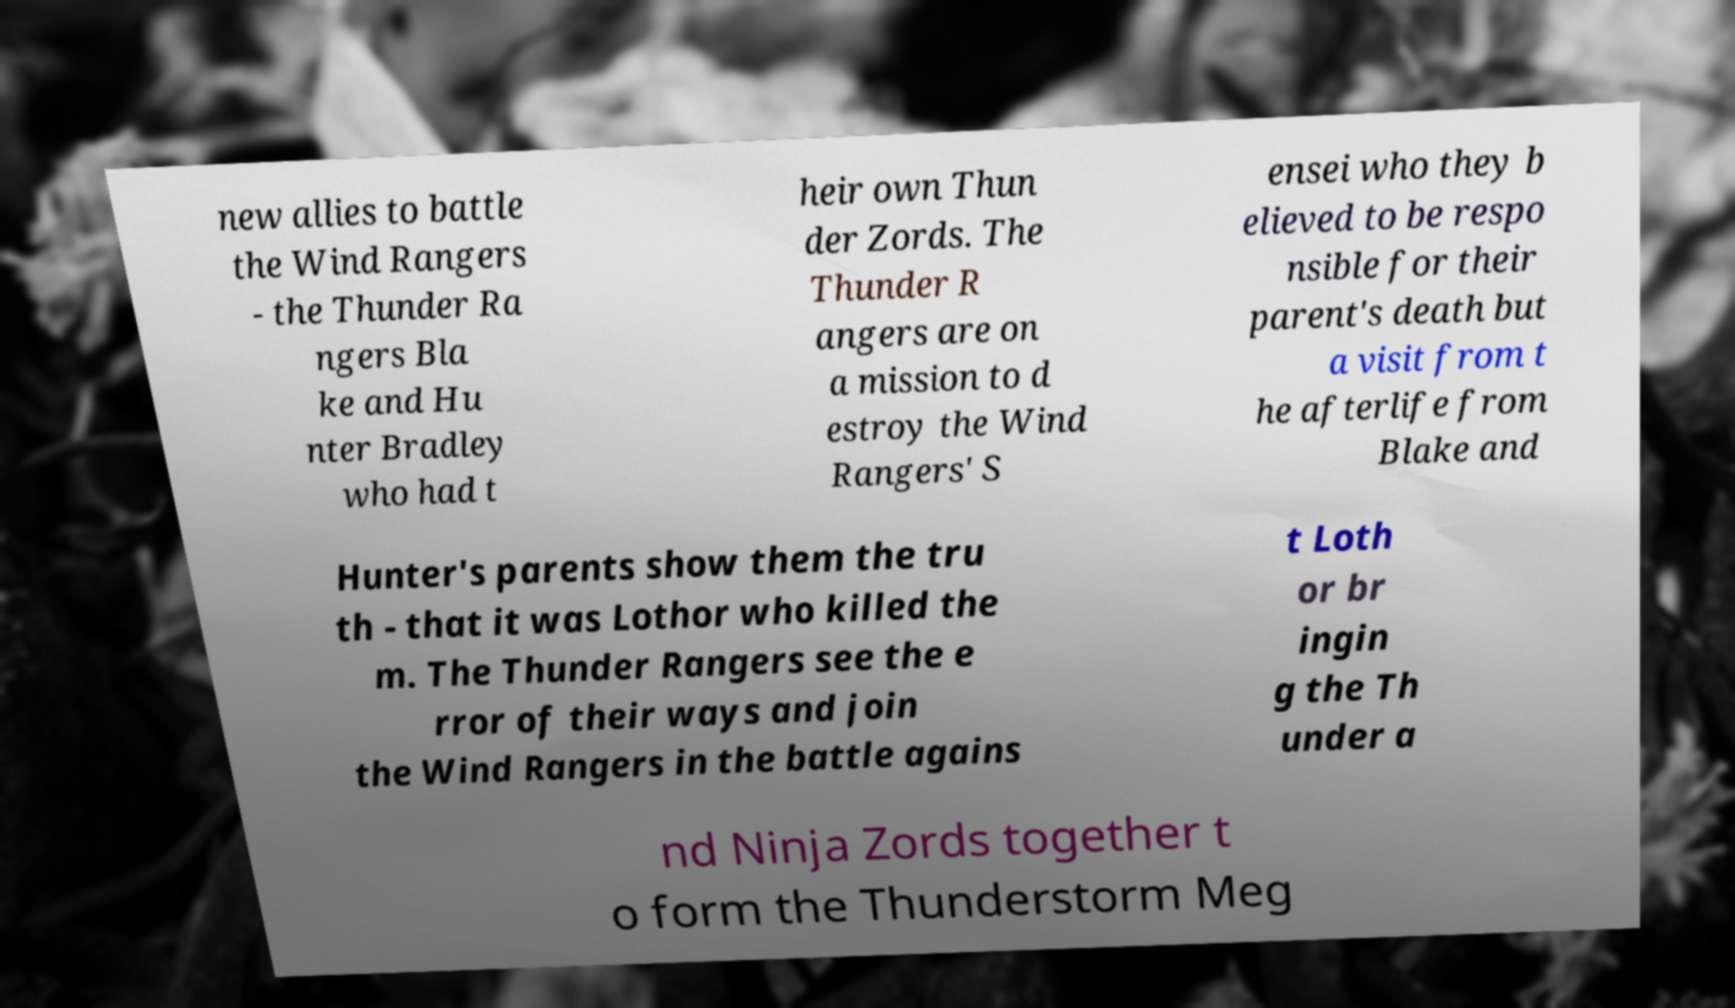Can you accurately transcribe the text from the provided image for me? new allies to battle the Wind Rangers - the Thunder Ra ngers Bla ke and Hu nter Bradley who had t heir own Thun der Zords. The Thunder R angers are on a mission to d estroy the Wind Rangers' S ensei who they b elieved to be respo nsible for their parent's death but a visit from t he afterlife from Blake and Hunter's parents show them the tru th - that it was Lothor who killed the m. The Thunder Rangers see the e rror of their ways and join the Wind Rangers in the battle agains t Loth or br ingin g the Th under a nd Ninja Zords together t o form the Thunderstorm Meg 